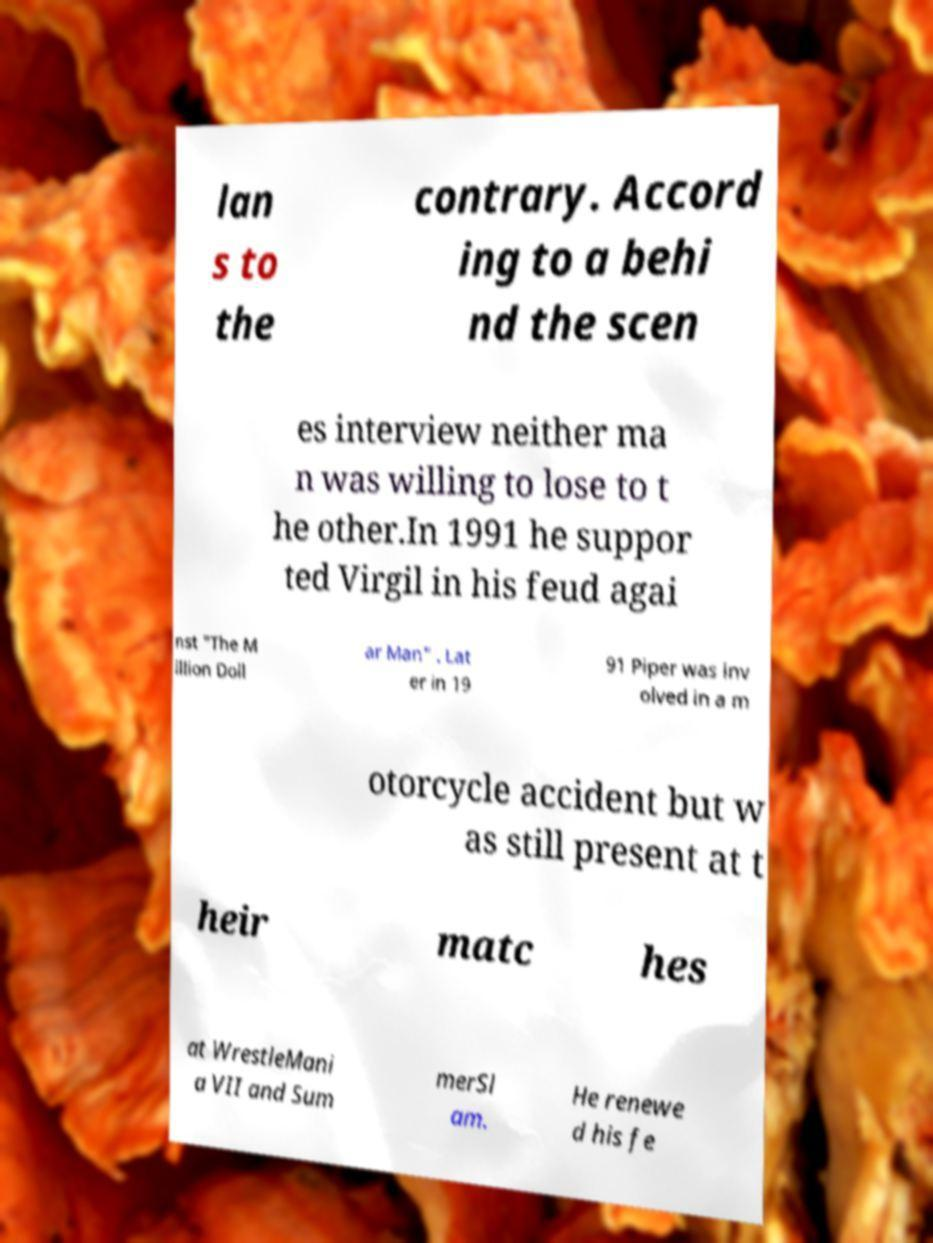What messages or text are displayed in this image? I need them in a readable, typed format. lan s to the contrary. Accord ing to a behi nd the scen es interview neither ma n was willing to lose to t he other.In 1991 he suppor ted Virgil in his feud agai nst "The M illion Doll ar Man" . Lat er in 19 91 Piper was inv olved in a m otorcycle accident but w as still present at t heir matc hes at WrestleMani a VII and Sum merSl am. He renewe d his fe 